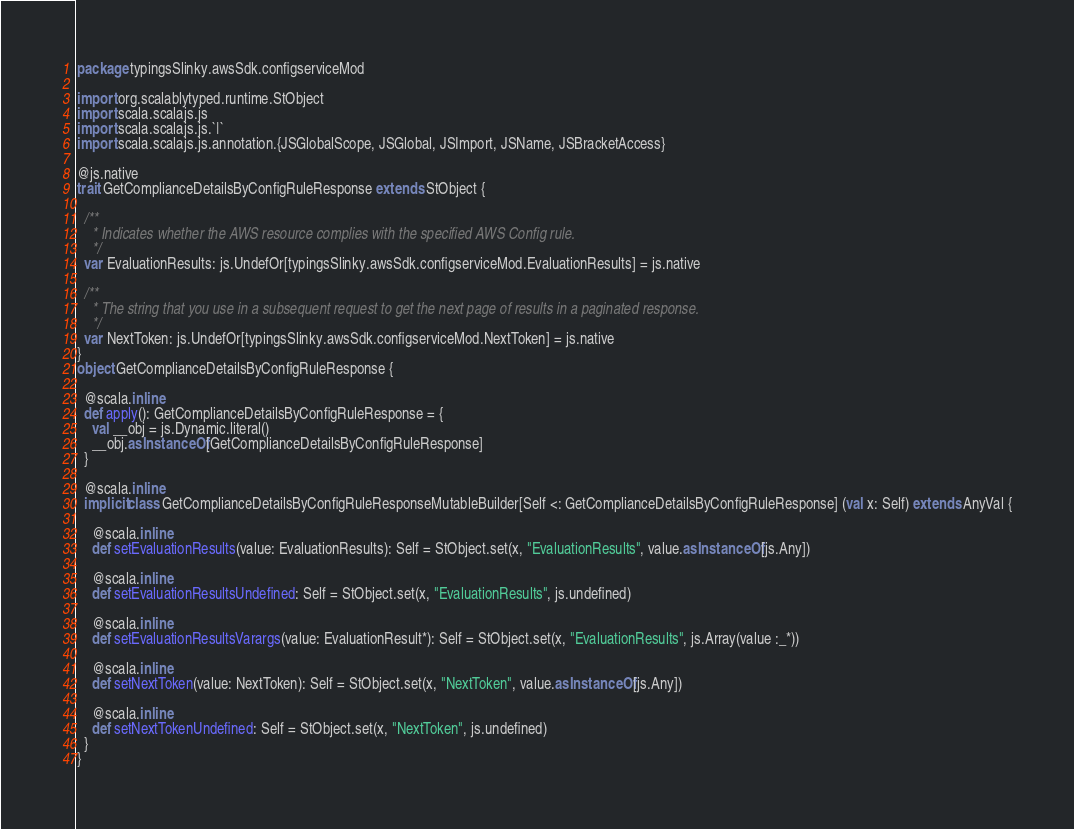<code> <loc_0><loc_0><loc_500><loc_500><_Scala_>package typingsSlinky.awsSdk.configserviceMod

import org.scalablytyped.runtime.StObject
import scala.scalajs.js
import scala.scalajs.js.`|`
import scala.scalajs.js.annotation.{JSGlobalScope, JSGlobal, JSImport, JSName, JSBracketAccess}

@js.native
trait GetComplianceDetailsByConfigRuleResponse extends StObject {
  
  /**
    * Indicates whether the AWS resource complies with the specified AWS Config rule.
    */
  var EvaluationResults: js.UndefOr[typingsSlinky.awsSdk.configserviceMod.EvaluationResults] = js.native
  
  /**
    * The string that you use in a subsequent request to get the next page of results in a paginated response.
    */
  var NextToken: js.UndefOr[typingsSlinky.awsSdk.configserviceMod.NextToken] = js.native
}
object GetComplianceDetailsByConfigRuleResponse {
  
  @scala.inline
  def apply(): GetComplianceDetailsByConfigRuleResponse = {
    val __obj = js.Dynamic.literal()
    __obj.asInstanceOf[GetComplianceDetailsByConfigRuleResponse]
  }
  
  @scala.inline
  implicit class GetComplianceDetailsByConfigRuleResponseMutableBuilder[Self <: GetComplianceDetailsByConfigRuleResponse] (val x: Self) extends AnyVal {
    
    @scala.inline
    def setEvaluationResults(value: EvaluationResults): Self = StObject.set(x, "EvaluationResults", value.asInstanceOf[js.Any])
    
    @scala.inline
    def setEvaluationResultsUndefined: Self = StObject.set(x, "EvaluationResults", js.undefined)
    
    @scala.inline
    def setEvaluationResultsVarargs(value: EvaluationResult*): Self = StObject.set(x, "EvaluationResults", js.Array(value :_*))
    
    @scala.inline
    def setNextToken(value: NextToken): Self = StObject.set(x, "NextToken", value.asInstanceOf[js.Any])
    
    @scala.inline
    def setNextTokenUndefined: Self = StObject.set(x, "NextToken", js.undefined)
  }
}
</code> 